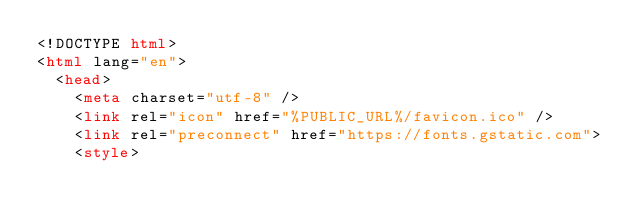Convert code to text. <code><loc_0><loc_0><loc_500><loc_500><_HTML_><!DOCTYPE html>
<html lang="en">
  <head>
    <meta charset="utf-8" />
    <link rel="icon" href="%PUBLIC_URL%/favicon.ico" />
    <link rel="preconnect" href="https://fonts.gstatic.com">
    <style></code> 